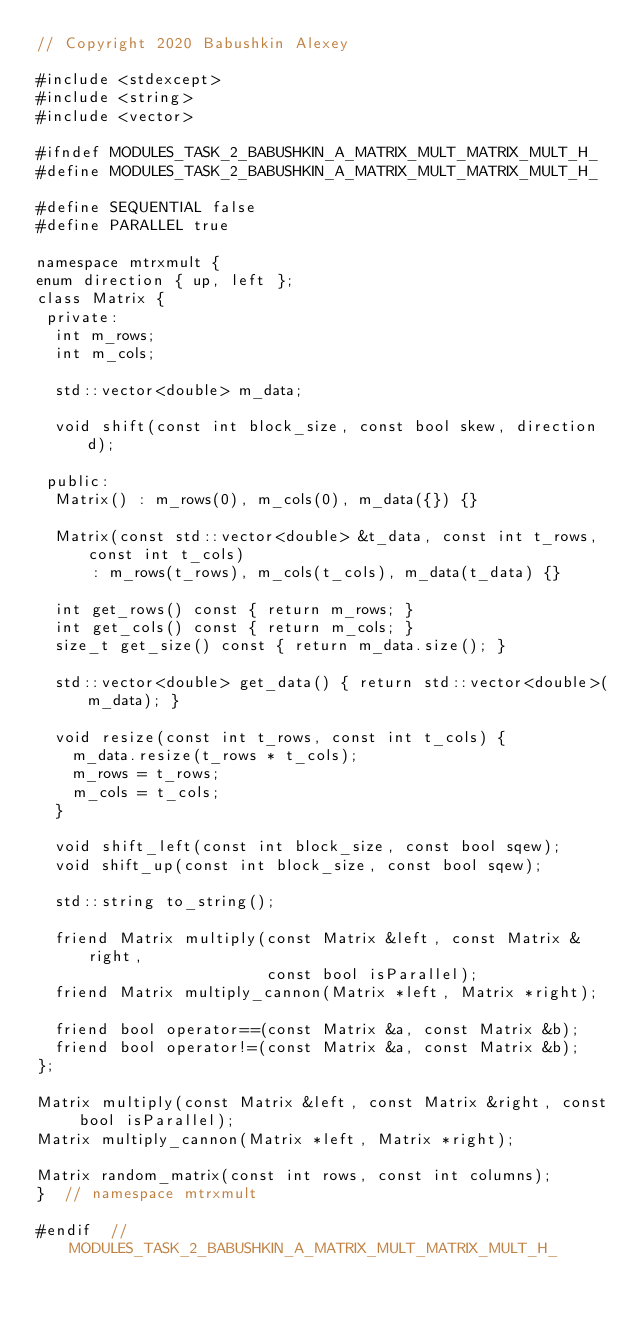<code> <loc_0><loc_0><loc_500><loc_500><_C_>// Copyright 2020 Babushkin Alexey

#include <stdexcept>
#include <string>
#include <vector>

#ifndef MODULES_TASK_2_BABUSHKIN_A_MATRIX_MULT_MATRIX_MULT_H_
#define MODULES_TASK_2_BABUSHKIN_A_MATRIX_MULT_MATRIX_MULT_H_

#define SEQUENTIAL false
#define PARALLEL true

namespace mtrxmult {
enum direction { up, left };
class Matrix {
 private:
  int m_rows;
  int m_cols;

  std::vector<double> m_data;

  void shift(const int block_size, const bool skew, direction d);

 public:
  Matrix() : m_rows(0), m_cols(0), m_data({}) {}

  Matrix(const std::vector<double> &t_data, const int t_rows, const int t_cols)
      : m_rows(t_rows), m_cols(t_cols), m_data(t_data) {}

  int get_rows() const { return m_rows; }
  int get_cols() const { return m_cols; }
  size_t get_size() const { return m_data.size(); }

  std::vector<double> get_data() { return std::vector<double>(m_data); }

  void resize(const int t_rows, const int t_cols) {
    m_data.resize(t_rows * t_cols);
    m_rows = t_rows;
    m_cols = t_cols;
  }

  void shift_left(const int block_size, const bool sqew);
  void shift_up(const int block_size, const bool sqew);

  std::string to_string();

  friend Matrix multiply(const Matrix &left, const Matrix &right,
                         const bool isParallel);
  friend Matrix multiply_cannon(Matrix *left, Matrix *right);

  friend bool operator==(const Matrix &a, const Matrix &b);
  friend bool operator!=(const Matrix &a, const Matrix &b);
};

Matrix multiply(const Matrix &left, const Matrix &right, const bool isParallel);
Matrix multiply_cannon(Matrix *left, Matrix *right);

Matrix random_matrix(const int rows, const int columns);
}  // namespace mtrxmult

#endif  // MODULES_TASK_2_BABUSHKIN_A_MATRIX_MULT_MATRIX_MULT_H_
</code> 